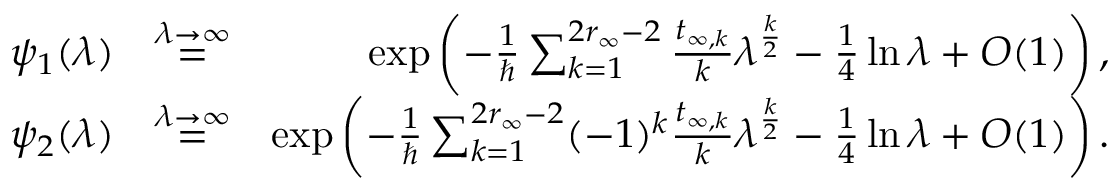<formula> <loc_0><loc_0><loc_500><loc_500>\begin{array} { r l r } { \psi _ { 1 } ( \lambda ) } & { \overset { \lambda \to \infty } { = } } & { \exp \left ( - \frac { 1 } { } \sum _ { k = 1 } ^ { 2 r _ { \infty } - 2 } \frac { t _ { \infty , k } } { k } \lambda ^ { \frac { k } { 2 } } - \frac { 1 } { 4 } \ln \lambda + O ( 1 ) \right ) , } \\ { \psi _ { 2 } ( \lambda ) } & { \overset { \lambda \to \infty } { = } } & { \exp \left ( - \frac { 1 } { } \sum _ { k = 1 } ^ { 2 r _ { \infty } - 2 } ( - 1 ) ^ { k } \frac { t _ { \infty , k } } { k } \lambda ^ { \frac { k } { 2 } } - \frac { 1 } { 4 } \ln \lambda + O ( 1 ) \right ) . } \end{array}</formula> 